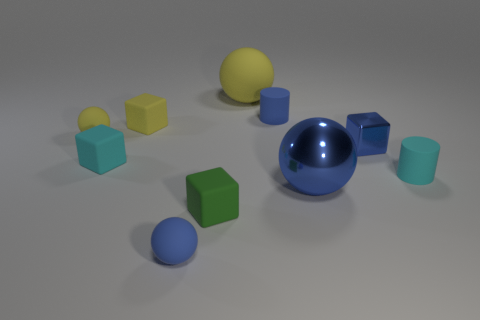There is a tiny cube that is the same color as the big metallic sphere; what is its material?
Your answer should be very brief. Metal. Is the small metal object the same color as the metal ball?
Keep it short and to the point. Yes. What is the shape of the blue metal object that is the same size as the green matte cube?
Your response must be concise. Cube. How many other things are the same color as the large rubber ball?
Provide a succinct answer. 2. Is the shape of the big thing in front of the large yellow sphere the same as the blue rubber thing that is in front of the tiny shiny cube?
Your answer should be compact. Yes. What number of things are either blue things that are behind the tiny blue shiny thing or big things that are in front of the small cyan cylinder?
Make the answer very short. 2. How many other objects are there of the same material as the tiny blue cylinder?
Your answer should be compact. 7. Are the small cyan cylinder that is on the right side of the tiny blue block and the small blue sphere made of the same material?
Your answer should be compact. Yes. Are there more cyan objects on the left side of the large matte thing than small blue spheres that are behind the blue matte sphere?
Give a very brief answer. Yes. How many objects are either cubes that are behind the tiny cyan rubber block or tiny yellow things?
Provide a succinct answer. 3. 